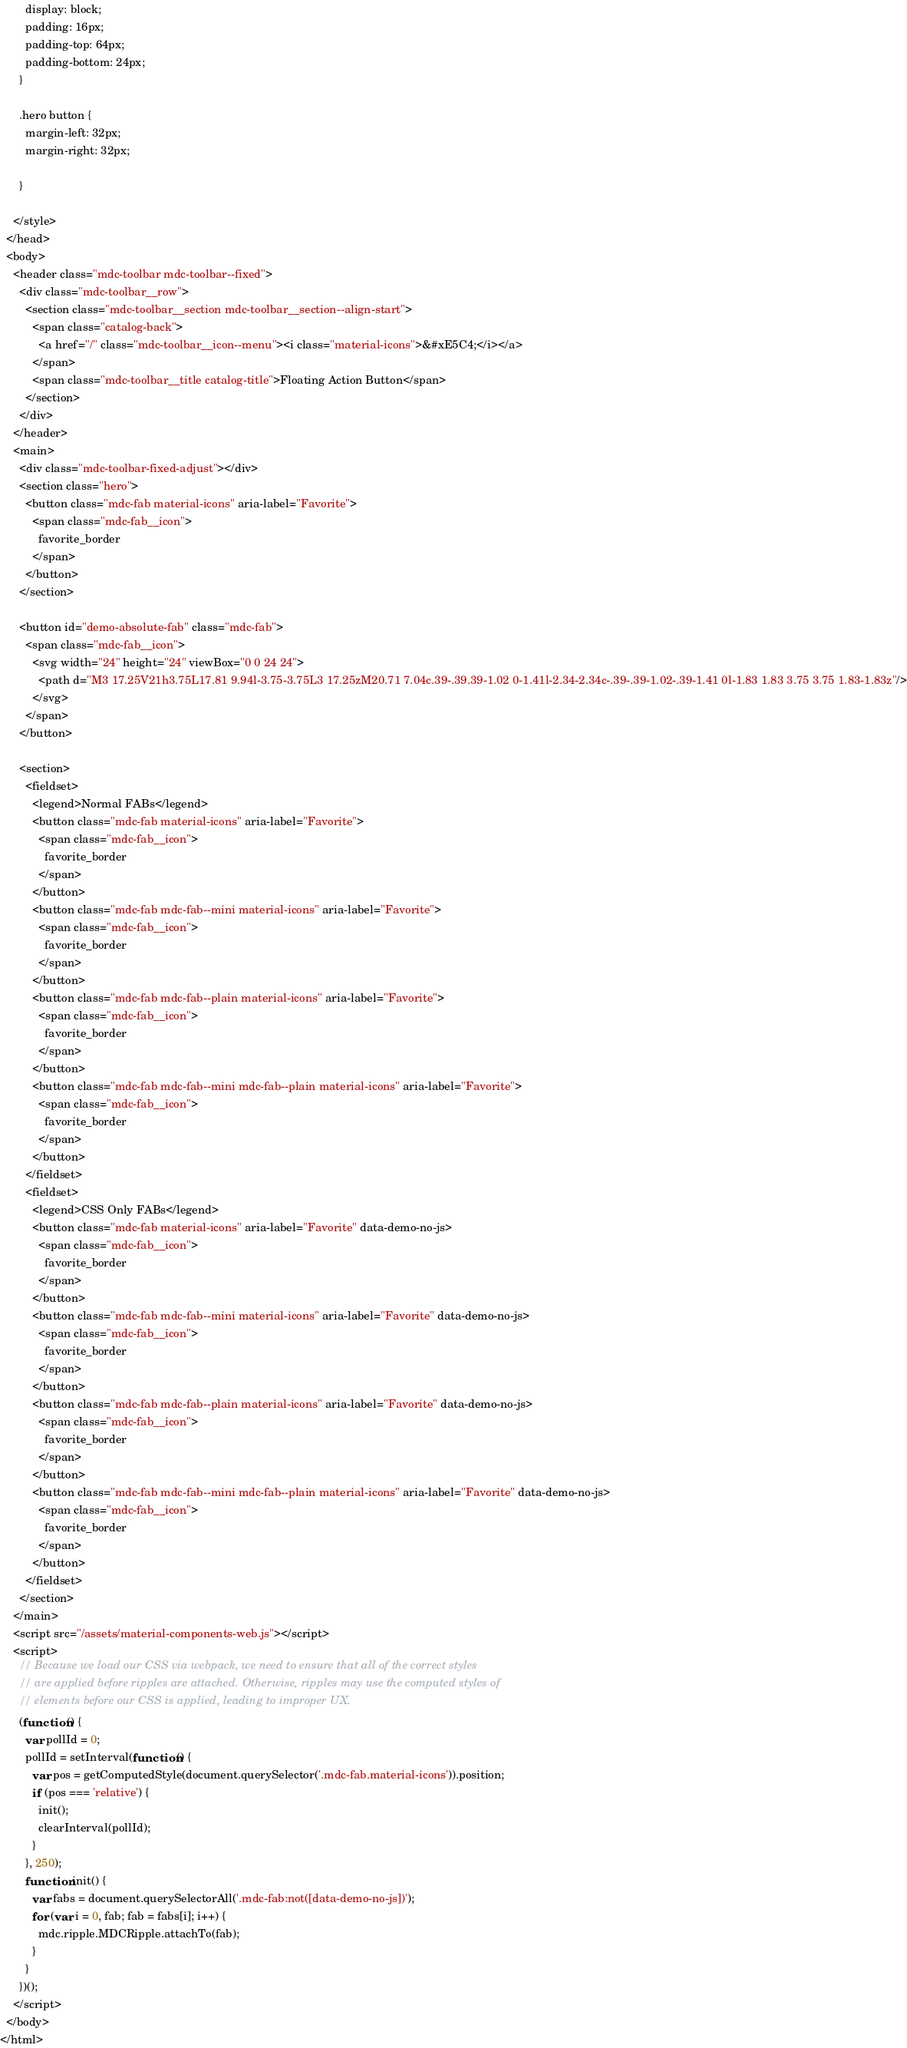<code> <loc_0><loc_0><loc_500><loc_500><_HTML_>        display: block;
        padding: 16px;
        padding-top: 64px;
        padding-bottom: 24px;
      }

      .hero button {
        margin-left: 32px;
        margin-right: 32px;

      }

    </style>
  </head>
  <body>
    <header class="mdc-toolbar mdc-toolbar--fixed">
      <div class="mdc-toolbar__row">
        <section class="mdc-toolbar__section mdc-toolbar__section--align-start">
          <span class="catalog-back">
            <a href="/" class="mdc-toolbar__icon--menu"><i class="material-icons">&#xE5C4;</i></a>
          </span>
          <span class="mdc-toolbar__title catalog-title">Floating Action Button</span>
        </section>
      </div>
    </header>
    <main>
      <div class="mdc-toolbar-fixed-adjust"></div>
      <section class="hero">
        <button class="mdc-fab material-icons" aria-label="Favorite">
          <span class="mdc-fab__icon">
            favorite_border
          </span>
        </button>
      </section>

      <button id="demo-absolute-fab" class="mdc-fab">
        <span class="mdc-fab__icon">
          <svg width="24" height="24" viewBox="0 0 24 24">
            <path d="M3 17.25V21h3.75L17.81 9.94l-3.75-3.75L3 17.25zM20.71 7.04c.39-.39.39-1.02 0-1.41l-2.34-2.34c-.39-.39-1.02-.39-1.41 0l-1.83 1.83 3.75 3.75 1.83-1.83z"/>
          </svg>
        </span>
      </button>

      <section>
        <fieldset>
          <legend>Normal FABs</legend>
          <button class="mdc-fab material-icons" aria-label="Favorite">
            <span class="mdc-fab__icon">
              favorite_border
            </span>
          </button>
          <button class="mdc-fab mdc-fab--mini material-icons" aria-label="Favorite">
            <span class="mdc-fab__icon">
              favorite_border
            </span>
          </button>
          <button class="mdc-fab mdc-fab--plain material-icons" aria-label="Favorite">
            <span class="mdc-fab__icon">
              favorite_border
            </span>
          </button>
          <button class="mdc-fab mdc-fab--mini mdc-fab--plain material-icons" aria-label="Favorite">
            <span class="mdc-fab__icon">
              favorite_border
            </span>
          </button>
        </fieldset>
        <fieldset>
          <legend>CSS Only FABs</legend>
          <button class="mdc-fab material-icons" aria-label="Favorite" data-demo-no-js>
            <span class="mdc-fab__icon">
              favorite_border
            </span>
          </button>
          <button class="mdc-fab mdc-fab--mini material-icons" aria-label="Favorite" data-demo-no-js>
            <span class="mdc-fab__icon">
              favorite_border
            </span>
          </button>
          <button class="mdc-fab mdc-fab--plain material-icons" aria-label="Favorite" data-demo-no-js>
            <span class="mdc-fab__icon">
              favorite_border
            </span>
          </button>
          <button class="mdc-fab mdc-fab--mini mdc-fab--plain material-icons" aria-label="Favorite" data-demo-no-js>
            <span class="mdc-fab__icon">
              favorite_border
            </span>
          </button>
        </fieldset>
      </section>
    </main>
    <script src="/assets/material-components-web.js"></script>
    <script>
      // Because we load our CSS via webpack, we need to ensure that all of the correct styles
      // are applied before ripples are attached. Otherwise, ripples may use the computed styles of
      // elements before our CSS is applied, leading to improper UX.
      (function() {
        var pollId = 0;
        pollId = setInterval(function() {
          var pos = getComputedStyle(document.querySelector('.mdc-fab.material-icons')).position;
          if (pos === 'relative') {
            init();
            clearInterval(pollId);
          }
        }, 250);
        function init() {
          var fabs = document.querySelectorAll('.mdc-fab:not([data-demo-no-js])');
          for (var i = 0, fab; fab = fabs[i]; i++) {
            mdc.ripple.MDCRipple.attachTo(fab);
          }
        }
      })();
    </script>
  </body>
</html>
</code> 